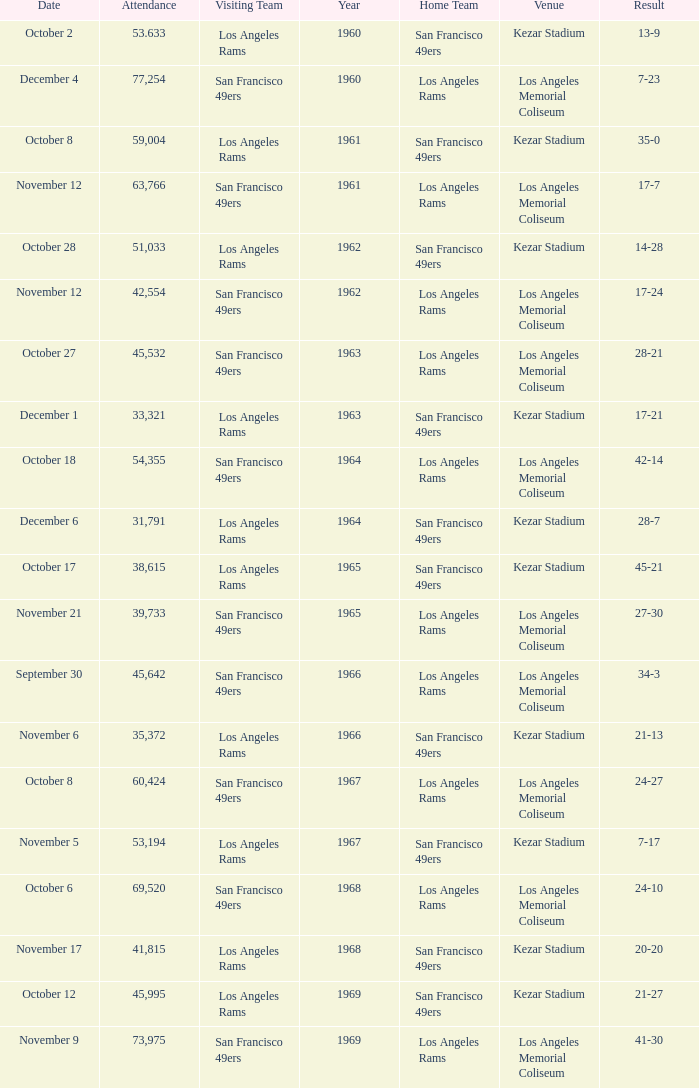What was the total attendance for a result of 7-23 before 1960? None. 